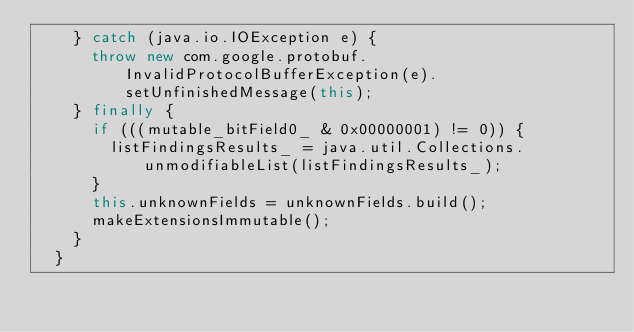Convert code to text. <code><loc_0><loc_0><loc_500><loc_500><_Java_>    } catch (java.io.IOException e) {
      throw new com.google.protobuf.InvalidProtocolBufferException(e).setUnfinishedMessage(this);
    } finally {
      if (((mutable_bitField0_ & 0x00000001) != 0)) {
        listFindingsResults_ = java.util.Collections.unmodifiableList(listFindingsResults_);
      }
      this.unknownFields = unknownFields.build();
      makeExtensionsImmutable();
    }
  }
</code> 